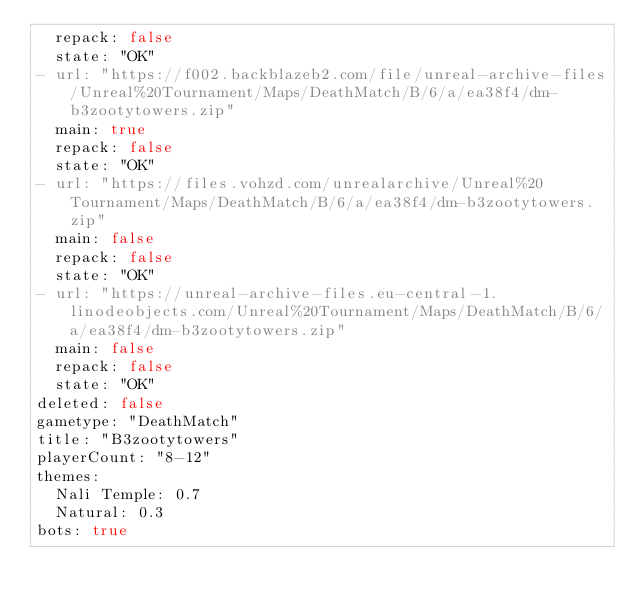<code> <loc_0><loc_0><loc_500><loc_500><_YAML_>  repack: false
  state: "OK"
- url: "https://f002.backblazeb2.com/file/unreal-archive-files/Unreal%20Tournament/Maps/DeathMatch/B/6/a/ea38f4/dm-b3zootytowers.zip"
  main: true
  repack: false
  state: "OK"
- url: "https://files.vohzd.com/unrealarchive/Unreal%20Tournament/Maps/DeathMatch/B/6/a/ea38f4/dm-b3zootytowers.zip"
  main: false
  repack: false
  state: "OK"
- url: "https://unreal-archive-files.eu-central-1.linodeobjects.com/Unreal%20Tournament/Maps/DeathMatch/B/6/a/ea38f4/dm-b3zootytowers.zip"
  main: false
  repack: false
  state: "OK"
deleted: false
gametype: "DeathMatch"
title: "B3zootytowers"
playerCount: "8-12"
themes:
  Nali Temple: 0.7
  Natural: 0.3
bots: true
</code> 